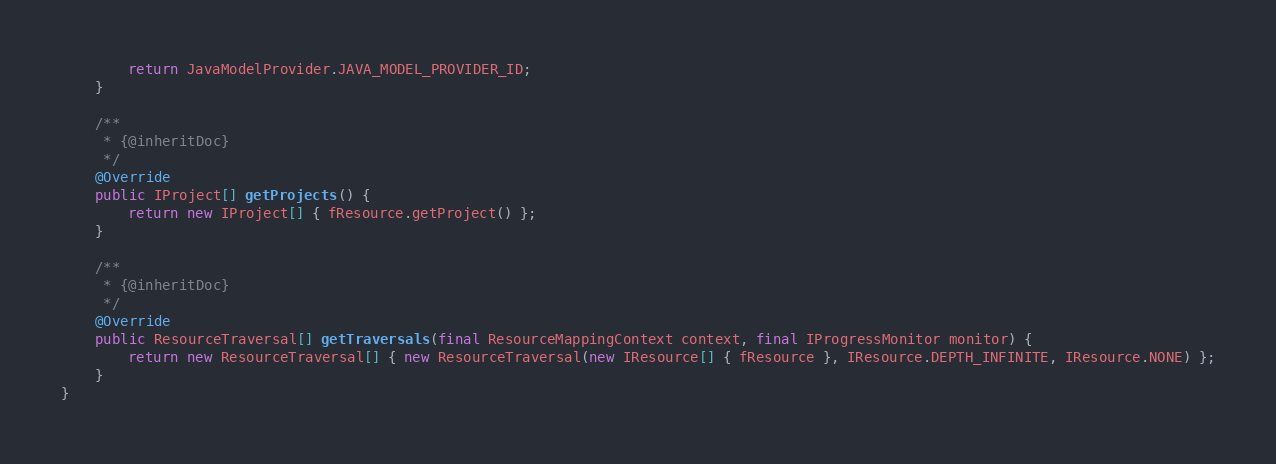Convert code to text. <code><loc_0><loc_0><loc_500><loc_500><_Java_>		return JavaModelProvider.JAVA_MODEL_PROVIDER_ID;
	}

	/**
	 * {@inheritDoc}
	 */
	@Override
	public IProject[] getProjects() {
		return new IProject[] { fResource.getProject() };
	}

	/**
	 * {@inheritDoc}
	 */
	@Override
	public ResourceTraversal[] getTraversals(final ResourceMappingContext context, final IProgressMonitor monitor) {
		return new ResourceTraversal[] { new ResourceTraversal(new IResource[] { fResource }, IResource.DEPTH_INFINITE, IResource.NONE) };
	}
}
</code> 